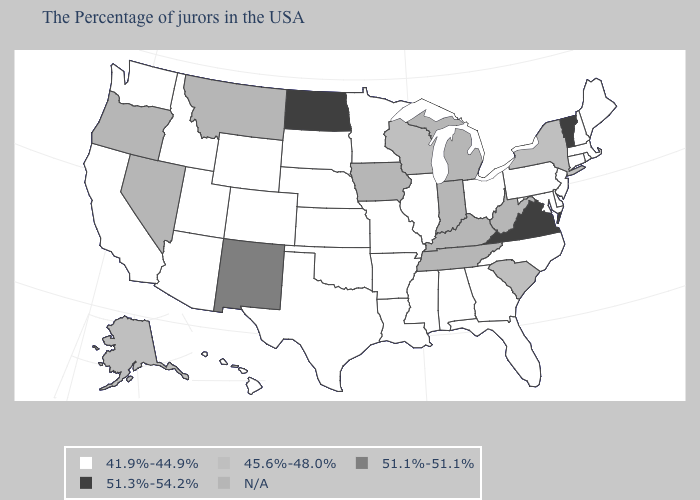Name the states that have a value in the range 51.1%-51.1%?
Give a very brief answer. New Mexico. Name the states that have a value in the range 45.6%-48.0%?
Quick response, please. New York, South Carolina, Wisconsin, Alaska. Name the states that have a value in the range 45.6%-48.0%?
Short answer required. New York, South Carolina, Wisconsin, Alaska. How many symbols are there in the legend?
Short answer required. 5. Name the states that have a value in the range 51.1%-51.1%?
Keep it brief. New Mexico. Does Minnesota have the lowest value in the USA?
Quick response, please. Yes. Among the states that border New Hampshire , which have the lowest value?
Keep it brief. Maine, Massachusetts. What is the value of Arizona?
Keep it brief. 41.9%-44.9%. Which states have the lowest value in the USA?
Concise answer only. Maine, Massachusetts, Rhode Island, New Hampshire, Connecticut, New Jersey, Delaware, Maryland, Pennsylvania, North Carolina, Ohio, Florida, Georgia, Alabama, Illinois, Mississippi, Louisiana, Missouri, Arkansas, Minnesota, Kansas, Nebraska, Oklahoma, Texas, South Dakota, Wyoming, Colorado, Utah, Arizona, Idaho, California, Washington, Hawaii. What is the lowest value in the USA?
Keep it brief. 41.9%-44.9%. Does the first symbol in the legend represent the smallest category?
Be succinct. Yes. Does the first symbol in the legend represent the smallest category?
Write a very short answer. Yes. Name the states that have a value in the range 51.3%-54.2%?
Quick response, please. Vermont, Virginia, North Dakota. 